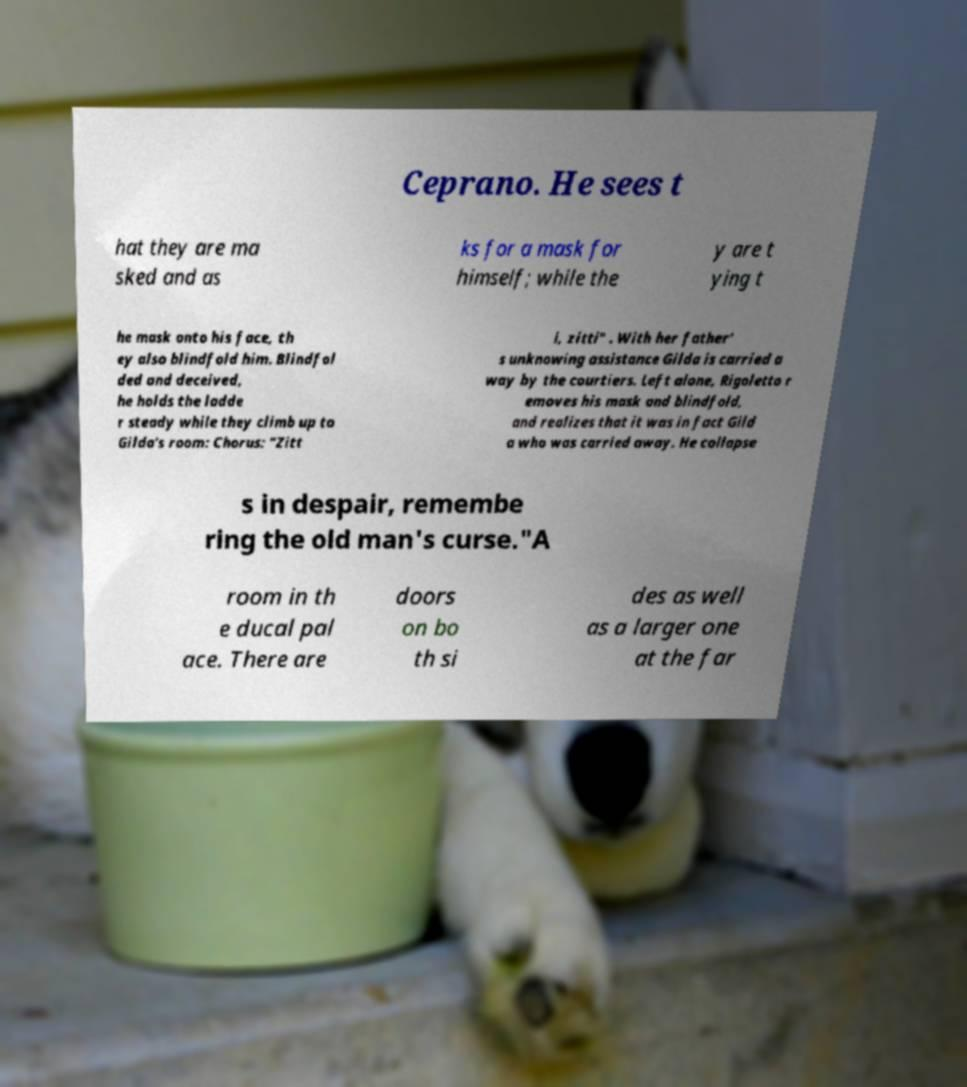What messages or text are displayed in this image? I need them in a readable, typed format. Ceprano. He sees t hat they are ma sked and as ks for a mask for himself; while the y are t ying t he mask onto his face, th ey also blindfold him. Blindfol ded and deceived, he holds the ladde r steady while they climb up to Gilda's room: Chorus: "Zitt i, zitti" . With her father' s unknowing assistance Gilda is carried a way by the courtiers. Left alone, Rigoletto r emoves his mask and blindfold, and realizes that it was in fact Gild a who was carried away. He collapse s in despair, remembe ring the old man's curse."A room in th e ducal pal ace. There are doors on bo th si des as well as a larger one at the far 